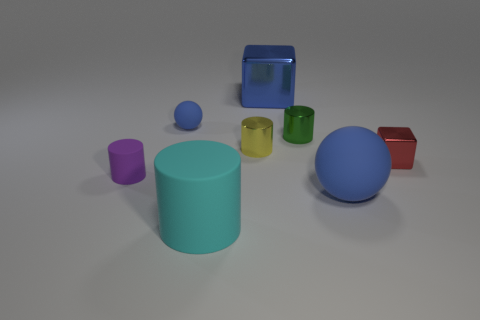Subtract all large cylinders. How many cylinders are left? 3 Add 1 tiny blue rubber blocks. How many objects exist? 9 Subtract all blue cubes. How many cubes are left? 1 Subtract 1 balls. How many balls are left? 1 Add 8 small matte objects. How many small matte objects are left? 10 Add 2 red shiny blocks. How many red shiny blocks exist? 3 Subtract 0 gray balls. How many objects are left? 8 Subtract all spheres. How many objects are left? 6 Subtract all cyan spheres. Subtract all cyan cubes. How many spheres are left? 2 Subtract all tiny purple blocks. Subtract all big rubber balls. How many objects are left? 7 